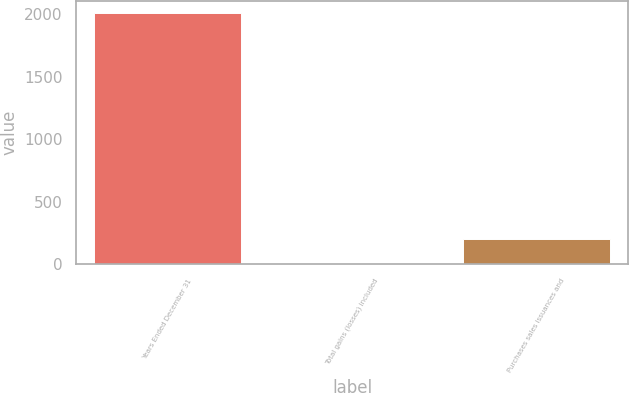<chart> <loc_0><loc_0><loc_500><loc_500><bar_chart><fcel>Years Ended December 31<fcel>Total gains (losses) included<fcel>Purchases sales issuances and<nl><fcel>2008<fcel>1<fcel>201.7<nl></chart> 